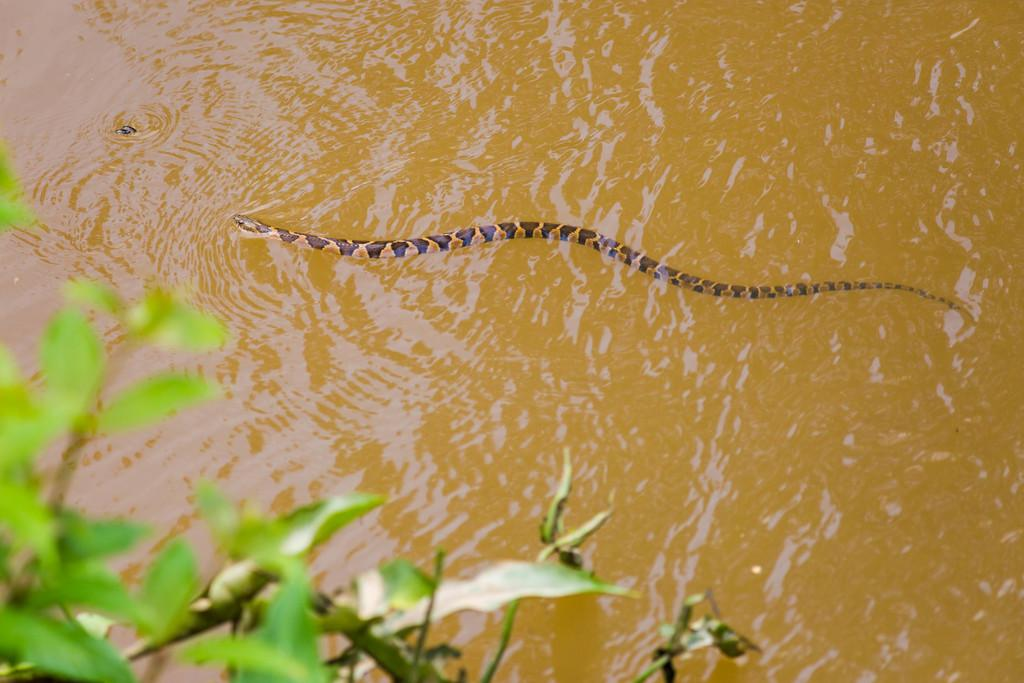What animal is present in the image? There is a snake in the image. Where is the snake located? The snake is on the water. What other living organism can be seen in the image? There is a plant in the image. What type of club can be seen in the image? There is no club present in the image. What color is the yarn used to create the snake's pattern in the image? The snake is not made of yarn, and there is no yarn present in the image. 